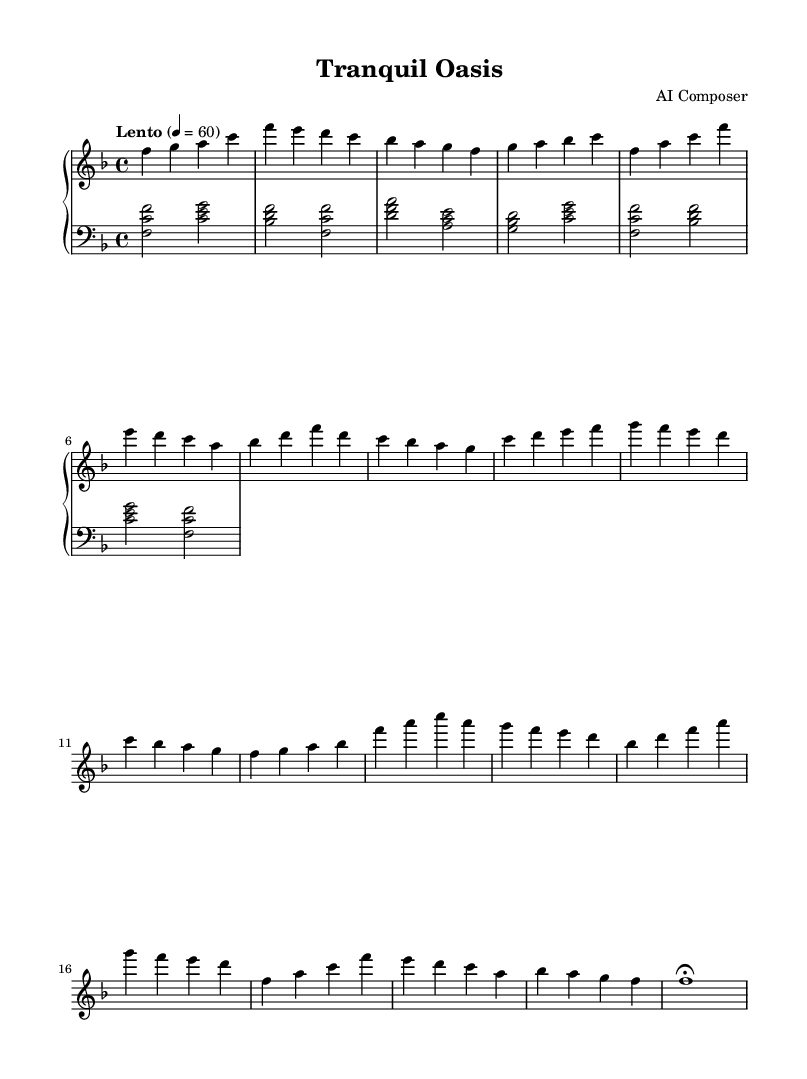What is the key signature of this music? The key signature is F major, which has one flat (B flat). This can be deduced from the global settings that indicate the key signature of the piece.
Answer: F major What is the time signature of this piece? The time signature is 4/4, as indicated in the global section of the code. This means there are four beats in each measure, and the quarter note gets one beat.
Answer: 4/4 What is the indicated tempo marking? The tempo marking is "Lento," which suggests a slow pace. In this case, the given note equals 60 beats per minute. The term "Lento" is typically associated with a slow tempo in classical music.
Answer: Lento How many measures are in the theme A section? Theme A consists of 4 measures. By counting the measures listed in the right hand section that correspond to Theme A, we can confirm this.
Answer: 4 Which instrument is specified for this score? The specified instrument for the score is the "acoustic grand." This is mentioned in the MIDI instrument settings for both the right and left hand staff.
Answer: Acoustic grand What is the final note of the piece? The final note of the piece is F, which is shown with a fermata indicating that it should be held longer. This can be identified at the end of the right hand section where it concludes with F1 followed by a fermata.
Answer: F 